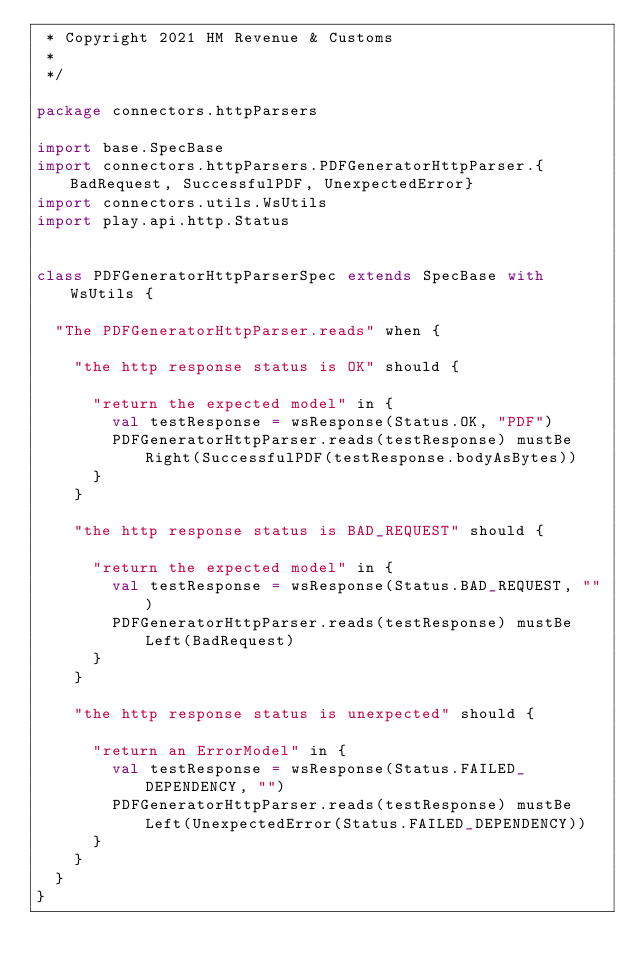Convert code to text. <code><loc_0><loc_0><loc_500><loc_500><_Scala_> * Copyright 2021 HM Revenue & Customs
 *
 */

package connectors.httpParsers

import base.SpecBase
import connectors.httpParsers.PDFGeneratorHttpParser.{BadRequest, SuccessfulPDF, UnexpectedError}
import connectors.utils.WsUtils
import play.api.http.Status


class PDFGeneratorHttpParserSpec extends SpecBase with WsUtils {

  "The PDFGeneratorHttpParser.reads" when {

    "the http response status is OK" should {

      "return the expected model" in {
        val testResponse = wsResponse(Status.OK, "PDF")
        PDFGeneratorHttpParser.reads(testResponse) mustBe Right(SuccessfulPDF(testResponse.bodyAsBytes))
      }
    }

    "the http response status is BAD_REQUEST" should {

      "return the expected model" in {
        val testResponse = wsResponse(Status.BAD_REQUEST, "")
        PDFGeneratorHttpParser.reads(testResponse) mustBe Left(BadRequest)
      }
    }

    "the http response status is unexpected" should {

      "return an ErrorModel" in {
        val testResponse = wsResponse(Status.FAILED_DEPENDENCY, "")
        PDFGeneratorHttpParser.reads(testResponse) mustBe Left(UnexpectedError(Status.FAILED_DEPENDENCY))
      }
    }
  }
}</code> 